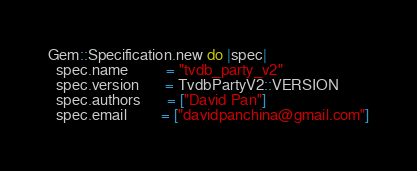Convert code to text. <code><loc_0><loc_0><loc_500><loc_500><_Ruby_>Gem::Specification.new do |spec|
  spec.name          = "tvdb_party_v2"
  spec.version       = TvdbPartyV2::VERSION
  spec.authors       = ["David Pan"]
  spec.email         = ["davidpanchina@gmail.com"]
</code> 